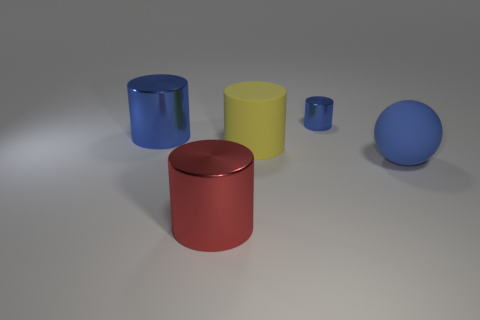Subtract 1 cylinders. How many cylinders are left? 3 Subtract all brown cylinders. Subtract all green blocks. How many cylinders are left? 4 Add 4 large purple matte objects. How many objects exist? 9 Subtract all spheres. How many objects are left? 4 Subtract 0 red balls. How many objects are left? 5 Subtract all large blue cylinders. Subtract all red shiny things. How many objects are left? 3 Add 5 yellow matte things. How many yellow matte things are left? 6 Add 2 brown metal cubes. How many brown metal cubes exist? 2 